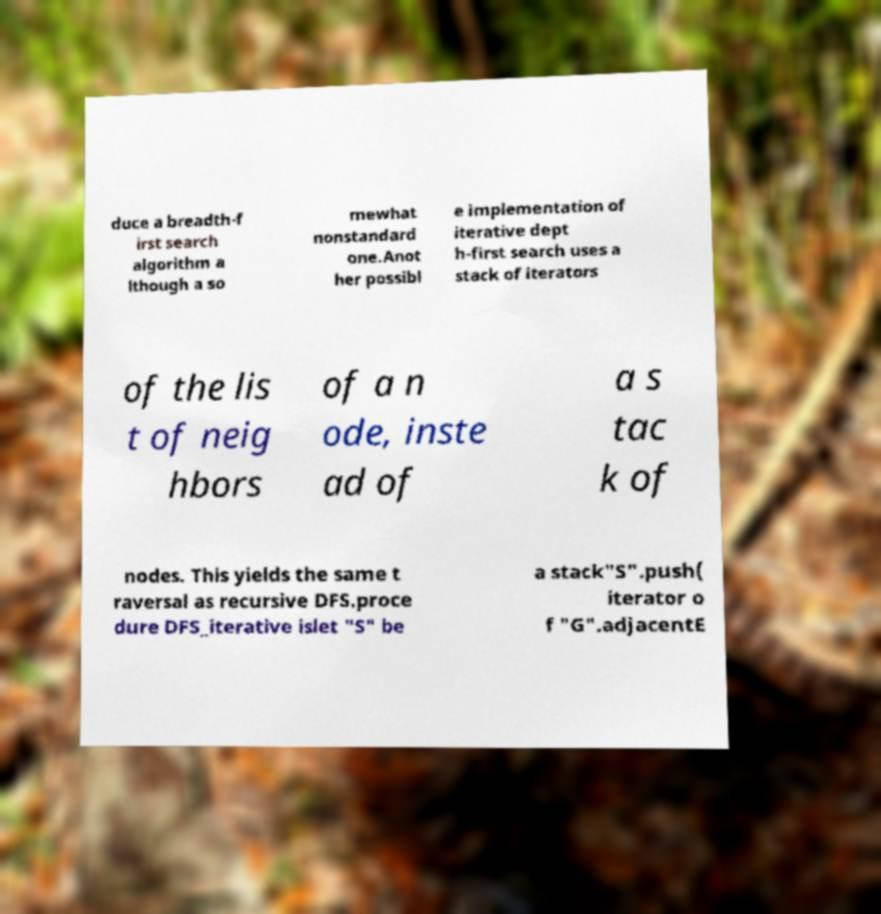What messages or text are displayed in this image? I need them in a readable, typed format. duce a breadth-f irst search algorithm a lthough a so mewhat nonstandard one.Anot her possibl e implementation of iterative dept h-first search uses a stack of iterators of the lis t of neig hbors of a n ode, inste ad of a s tac k of nodes. This yields the same t raversal as recursive DFS.proce dure DFS_iterative islet "S" be a stack"S".push( iterator o f "G".adjacentE 